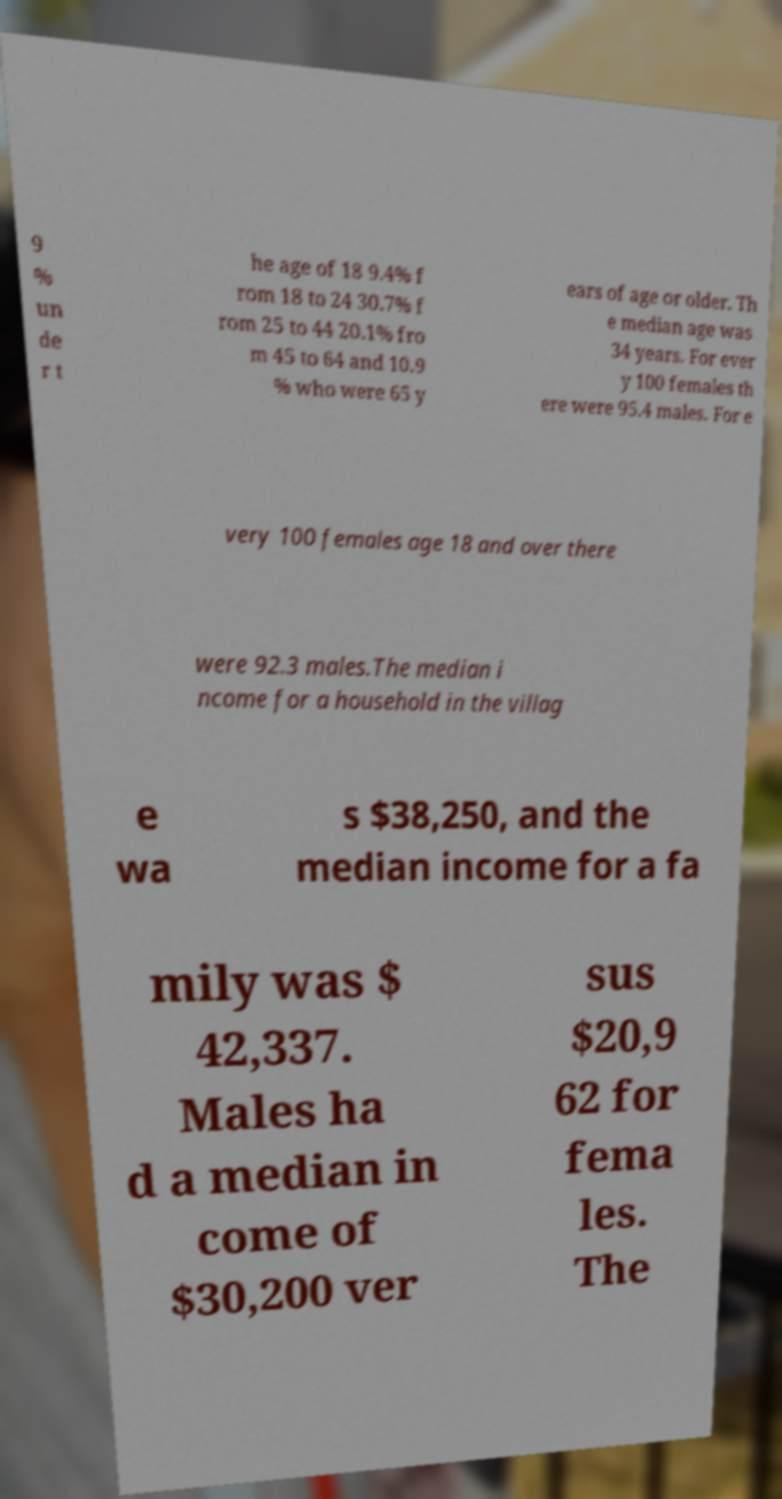Can you accurately transcribe the text from the provided image for me? 9 % un de r t he age of 18 9.4% f rom 18 to 24 30.7% f rom 25 to 44 20.1% fro m 45 to 64 and 10.9 % who were 65 y ears of age or older. Th e median age was 34 years. For ever y 100 females th ere were 95.4 males. For e very 100 females age 18 and over there were 92.3 males.The median i ncome for a household in the villag e wa s $38,250, and the median income for a fa mily was $ 42,337. Males ha d a median in come of $30,200 ver sus $20,9 62 for fema les. The 